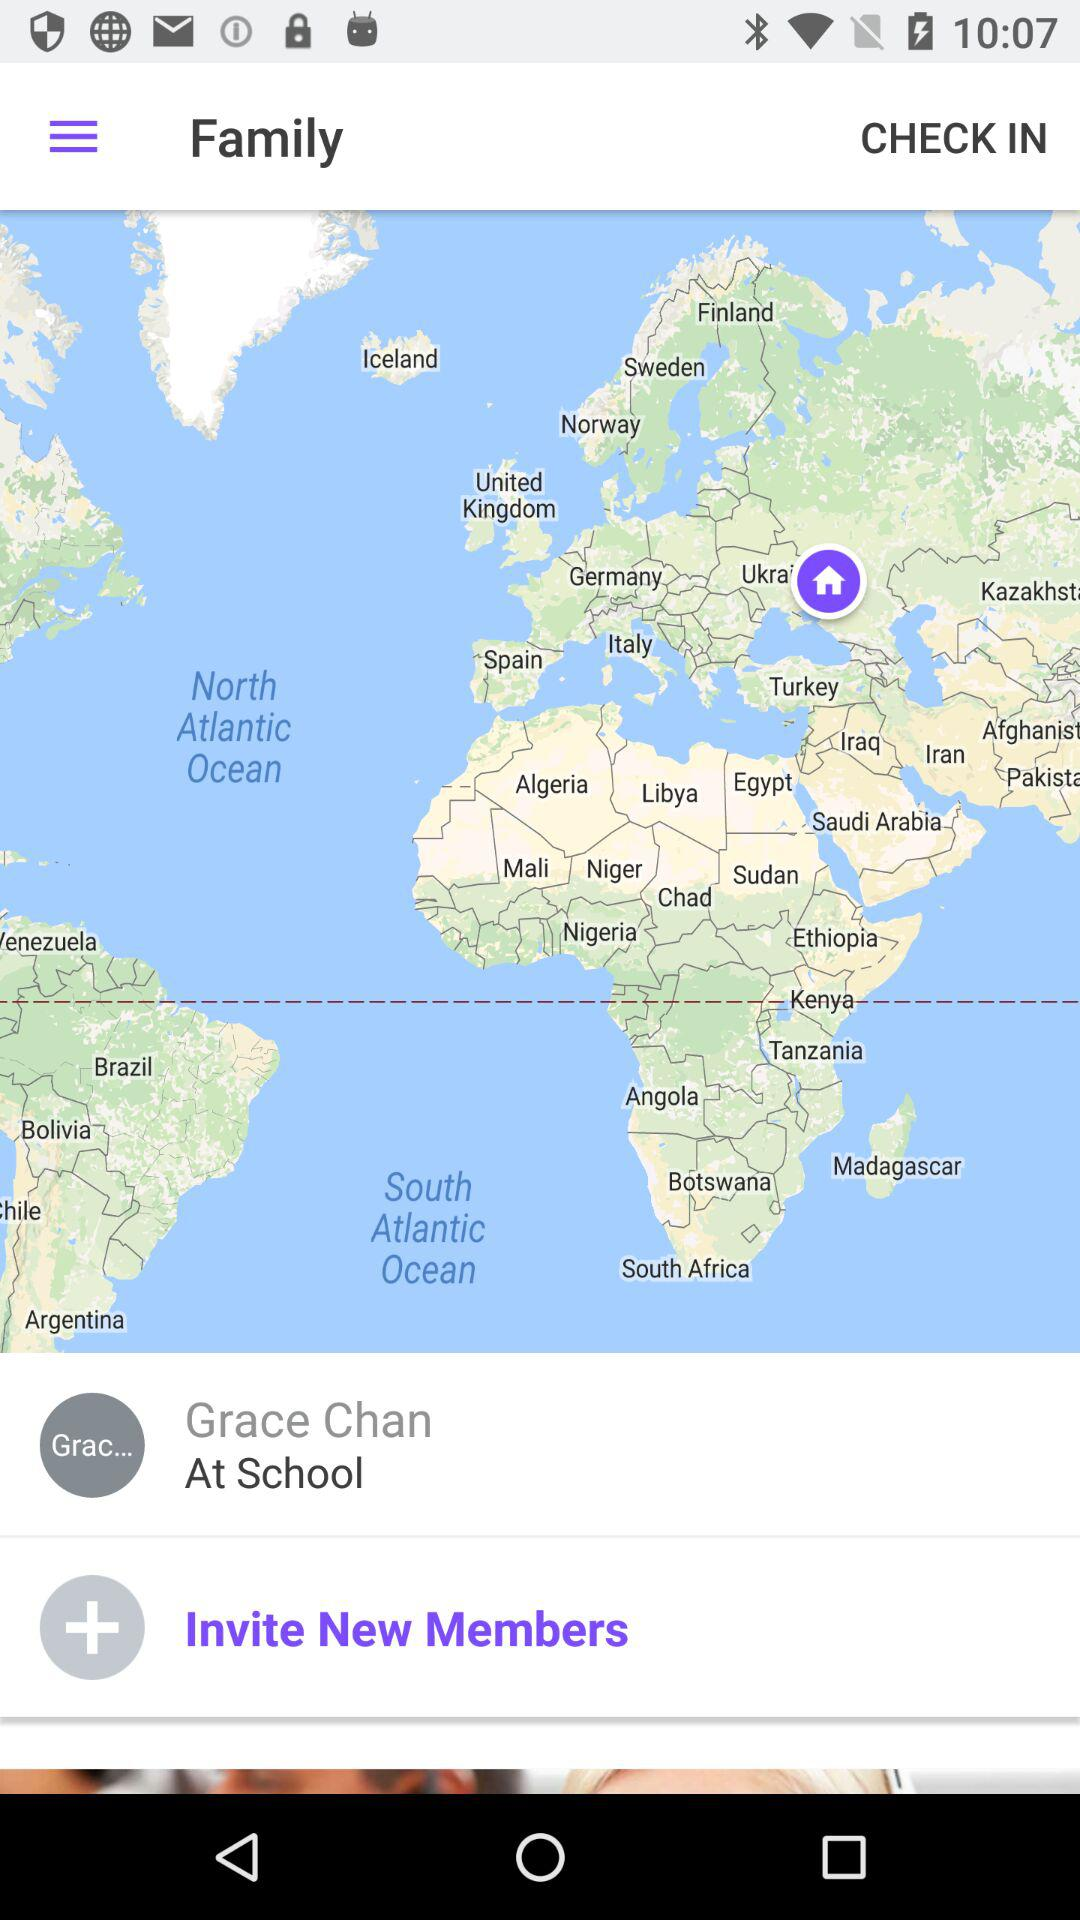Where is Grace Chan? Grace Chan is at school. 